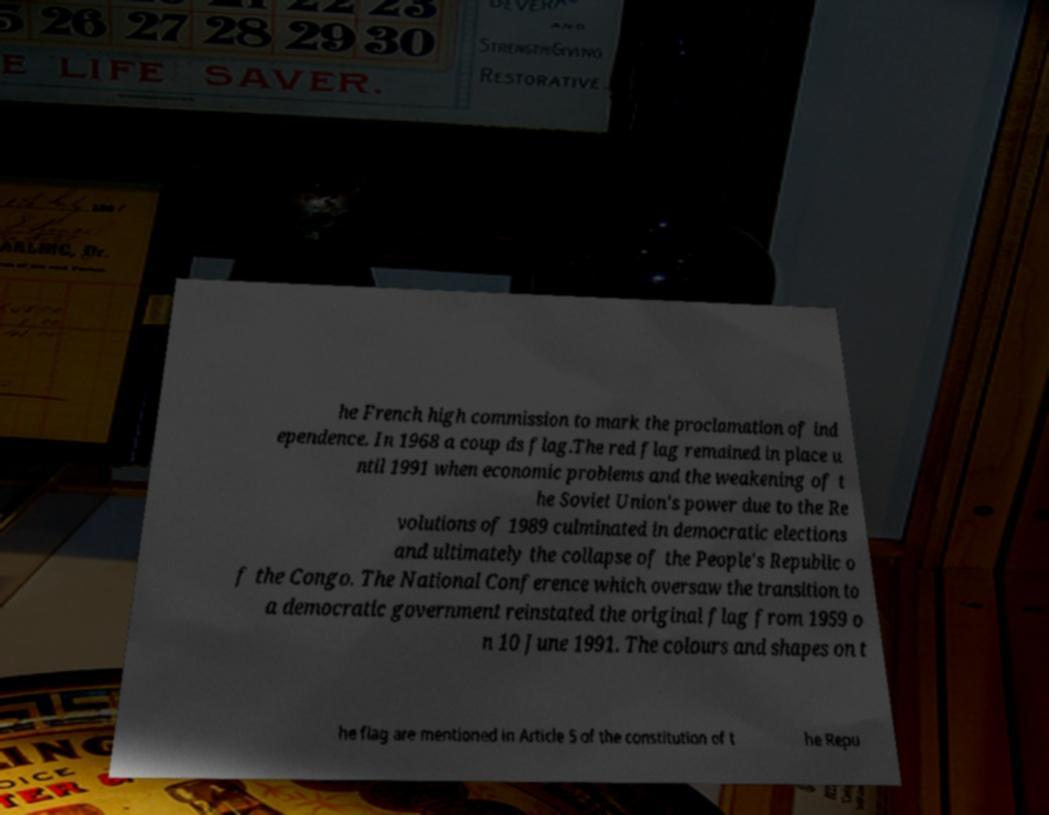Please identify and transcribe the text found in this image. he French high commission to mark the proclamation of ind ependence. In 1968 a coup ds flag.The red flag remained in place u ntil 1991 when economic problems and the weakening of t he Soviet Union's power due to the Re volutions of 1989 culminated in democratic elections and ultimately the collapse of the People's Republic o f the Congo. The National Conference which oversaw the transition to a democratic government reinstated the original flag from 1959 o n 10 June 1991. The colours and shapes on t he flag are mentioned in Article 5 of the constitution of t he Repu 